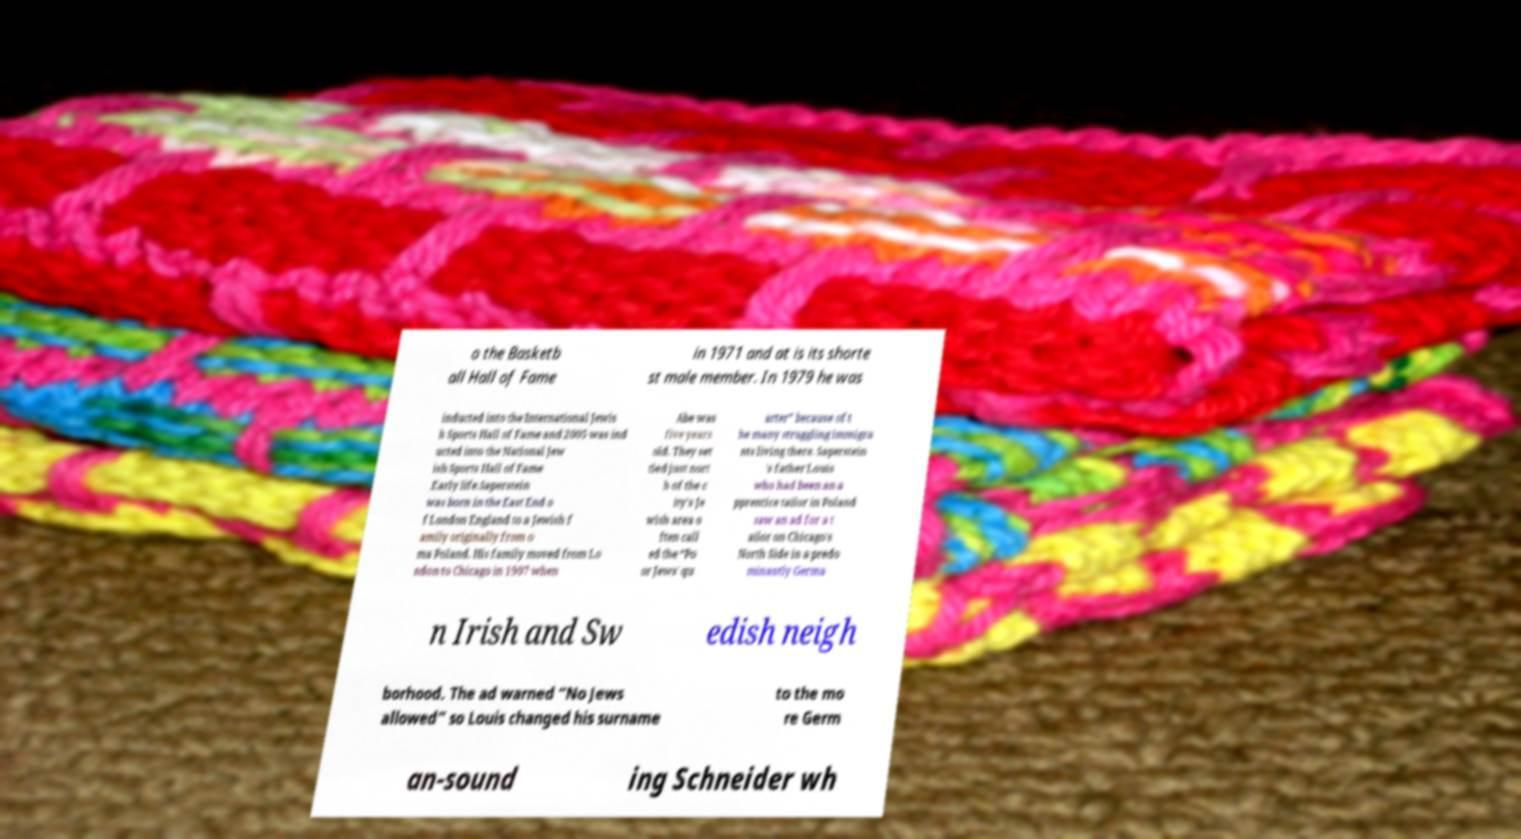Please identify and transcribe the text found in this image. o the Basketb all Hall of Fame in 1971 and at is its shorte st male member. In 1979 he was inducted into the International Jewis h Sports Hall of Fame and 2005 was ind ucted into the National Jew ish Sports Hall of Fame .Early life.Saperstein was born in the East End o f London England to a Jewish f amily originally from o ma Poland. His family moved from Lo ndon to Chicago in 1907 when Abe was five years old. They set tled just nort h of the c ity's Je wish area o ften call ed the “Po or Jews' qu arter” because of t he many struggling immigra nts living there. Saperstein 's father Louis who had been an a pprentice tailor in Poland saw an ad for a t ailor on Chicago's North Side in a predo minantly Germa n Irish and Sw edish neigh borhood. The ad warned “No Jews allowed” so Louis changed his surname to the mo re Germ an-sound ing Schneider wh 